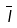Convert formula to latex. <formula><loc_0><loc_0><loc_500><loc_500>\overline { I }</formula> 